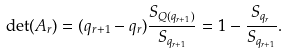<formula> <loc_0><loc_0><loc_500><loc_500>\det ( A _ { r } ) = ( q _ { r + 1 } - q _ { r } ) \frac { S _ { Q ( q _ { r + 1 } ) } } { S _ { q _ { r + 1 } } } = 1 - \frac { S _ { q _ { r } } } { S _ { q _ { r + 1 } } } .</formula> 